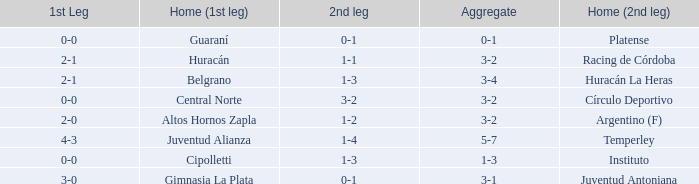Who played at home for the second leg with a score of 0-1 and tied 0-0 in the first leg? Platense. 